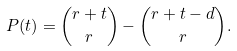Convert formula to latex. <formula><loc_0><loc_0><loc_500><loc_500>P ( t ) = \binom { r + t } { r } - \binom { r + t - d } { r } .</formula> 